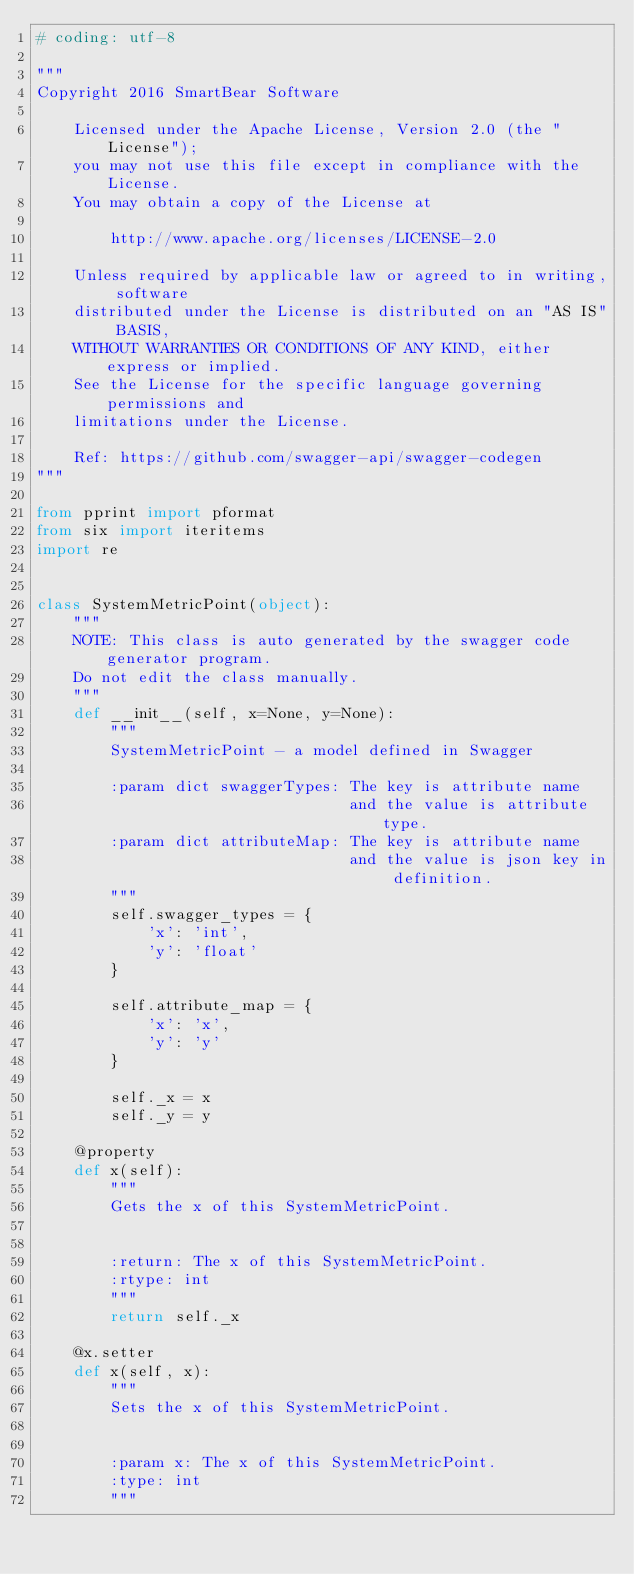Convert code to text. <code><loc_0><loc_0><loc_500><loc_500><_Python_># coding: utf-8

"""
Copyright 2016 SmartBear Software

    Licensed under the Apache License, Version 2.0 (the "License");
    you may not use this file except in compliance with the License.
    You may obtain a copy of the License at

        http://www.apache.org/licenses/LICENSE-2.0

    Unless required by applicable law or agreed to in writing, software
    distributed under the License is distributed on an "AS IS" BASIS,
    WITHOUT WARRANTIES OR CONDITIONS OF ANY KIND, either express or implied.
    See the License for the specific language governing permissions and
    limitations under the License.

    Ref: https://github.com/swagger-api/swagger-codegen
"""

from pprint import pformat
from six import iteritems
import re


class SystemMetricPoint(object):
    """
    NOTE: This class is auto generated by the swagger code generator program.
    Do not edit the class manually.
    """
    def __init__(self, x=None, y=None):
        """
        SystemMetricPoint - a model defined in Swagger

        :param dict swaggerTypes: The key is attribute name
                                  and the value is attribute type.
        :param dict attributeMap: The key is attribute name
                                  and the value is json key in definition.
        """
        self.swagger_types = {
            'x': 'int',
            'y': 'float'
        }

        self.attribute_map = {
            'x': 'x',
            'y': 'y'
        }

        self._x = x
        self._y = y

    @property
    def x(self):
        """
        Gets the x of this SystemMetricPoint.


        :return: The x of this SystemMetricPoint.
        :rtype: int
        """
        return self._x

    @x.setter
    def x(self, x):
        """
        Sets the x of this SystemMetricPoint.


        :param x: The x of this SystemMetricPoint.
        :type: int
        """</code> 